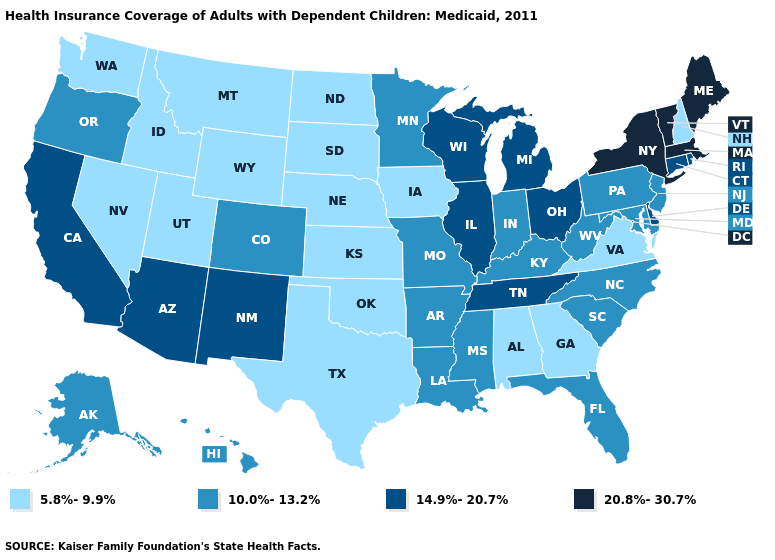What is the value of Iowa?
Concise answer only. 5.8%-9.9%. Which states have the lowest value in the USA?
Concise answer only. Alabama, Georgia, Idaho, Iowa, Kansas, Montana, Nebraska, Nevada, New Hampshire, North Dakota, Oklahoma, South Dakota, Texas, Utah, Virginia, Washington, Wyoming. Does Georgia have the highest value in the USA?
Quick response, please. No. Does Nebraska have the same value as Pennsylvania?
Quick response, please. No. Which states hav the highest value in the West?
Be succinct. Arizona, California, New Mexico. Name the states that have a value in the range 5.8%-9.9%?
Write a very short answer. Alabama, Georgia, Idaho, Iowa, Kansas, Montana, Nebraska, Nevada, New Hampshire, North Dakota, Oklahoma, South Dakota, Texas, Utah, Virginia, Washington, Wyoming. Which states have the highest value in the USA?
Be succinct. Maine, Massachusetts, New York, Vermont. Does the first symbol in the legend represent the smallest category?
Keep it brief. Yes. What is the highest value in states that border West Virginia?
Concise answer only. 14.9%-20.7%. Name the states that have a value in the range 5.8%-9.9%?
Concise answer only. Alabama, Georgia, Idaho, Iowa, Kansas, Montana, Nebraska, Nevada, New Hampshire, North Dakota, Oklahoma, South Dakota, Texas, Utah, Virginia, Washington, Wyoming. Name the states that have a value in the range 20.8%-30.7%?
Keep it brief. Maine, Massachusetts, New York, Vermont. What is the value of Wisconsin?
Concise answer only. 14.9%-20.7%. What is the highest value in the Northeast ?
Short answer required. 20.8%-30.7%. What is the highest value in the USA?
Answer briefly. 20.8%-30.7%. What is the value of North Carolina?
Be succinct. 10.0%-13.2%. 